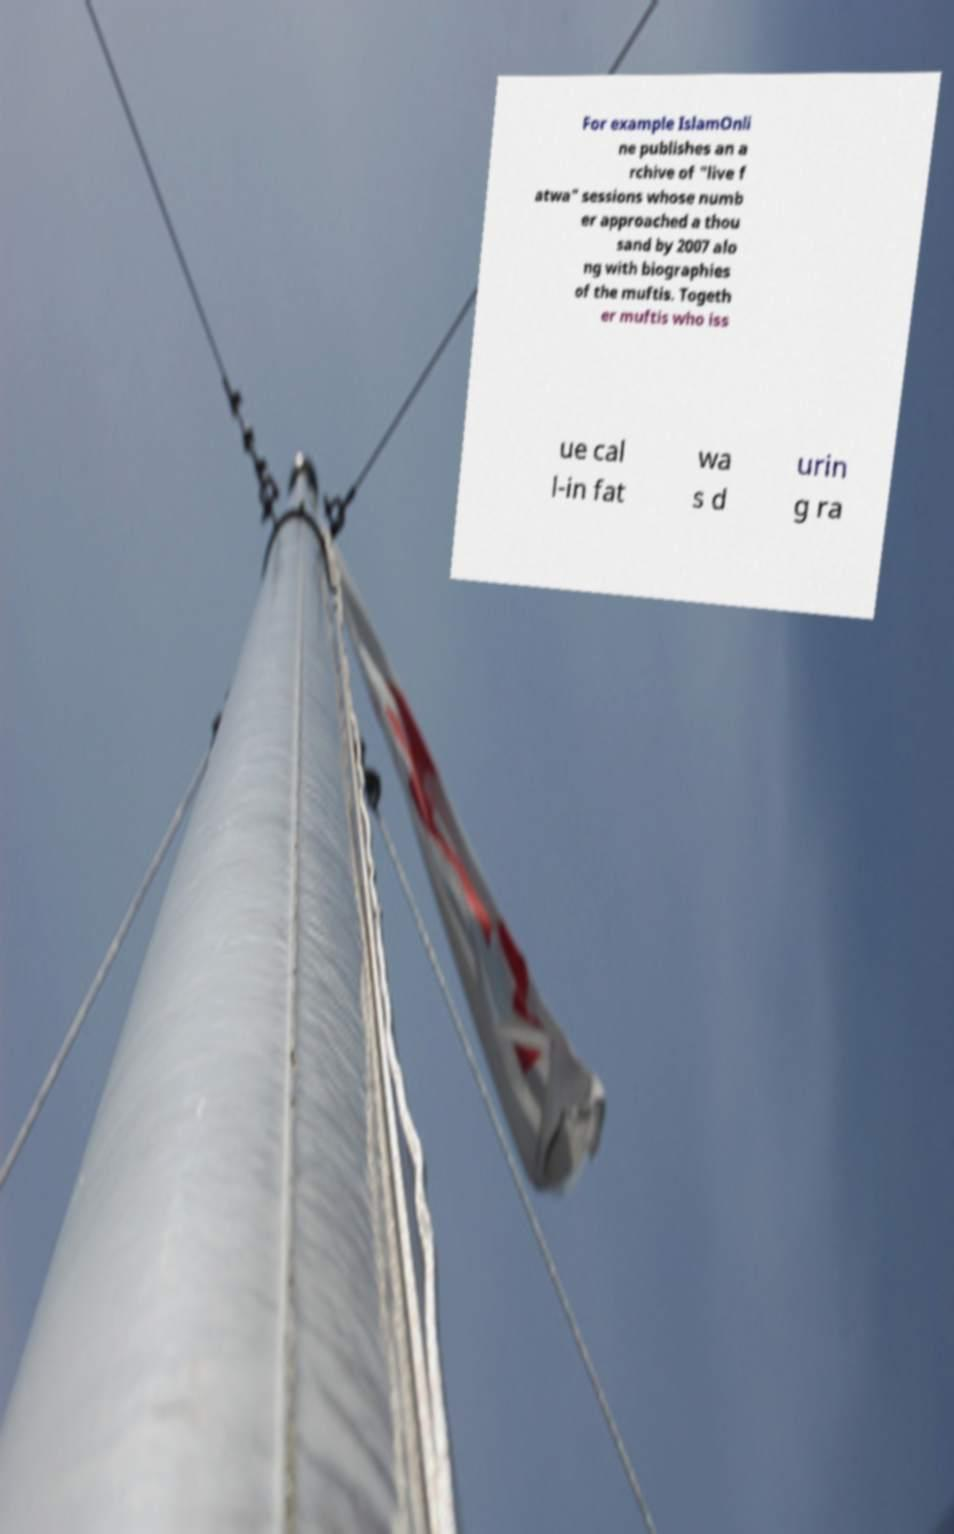There's text embedded in this image that I need extracted. Can you transcribe it verbatim? For example IslamOnli ne publishes an a rchive of "live f atwa" sessions whose numb er approached a thou sand by 2007 alo ng with biographies of the muftis. Togeth er muftis who iss ue cal l-in fat wa s d urin g ra 